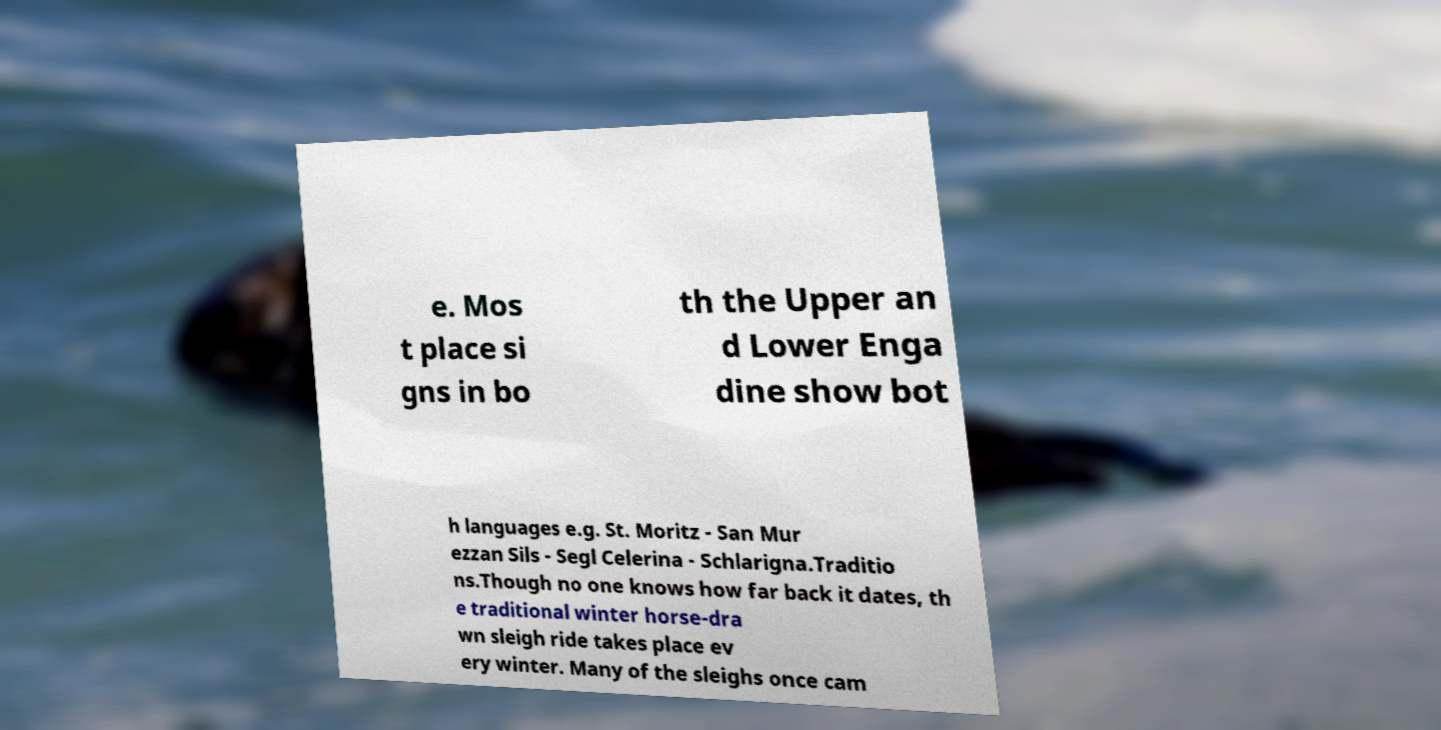Please read and relay the text visible in this image. What does it say? e. Mos t place si gns in bo th the Upper an d Lower Enga dine show bot h languages e.g. St. Moritz - San Mur ezzan Sils - Segl Celerina - Schlarigna.Traditio ns.Though no one knows how far back it dates, th e traditional winter horse-dra wn sleigh ride takes place ev ery winter. Many of the sleighs once cam 